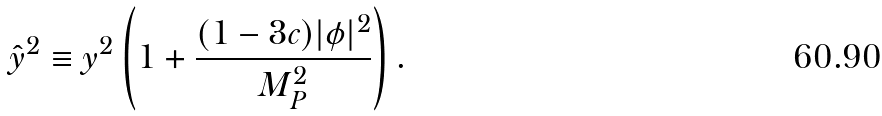<formula> <loc_0><loc_0><loc_500><loc_500>\hat { y } ^ { 2 } \equiv y ^ { 2 } \left ( 1 + \frac { ( 1 - 3 c ) | \phi | ^ { 2 } } { M _ { \text {P} } ^ { 2 } } \right ) .</formula> 